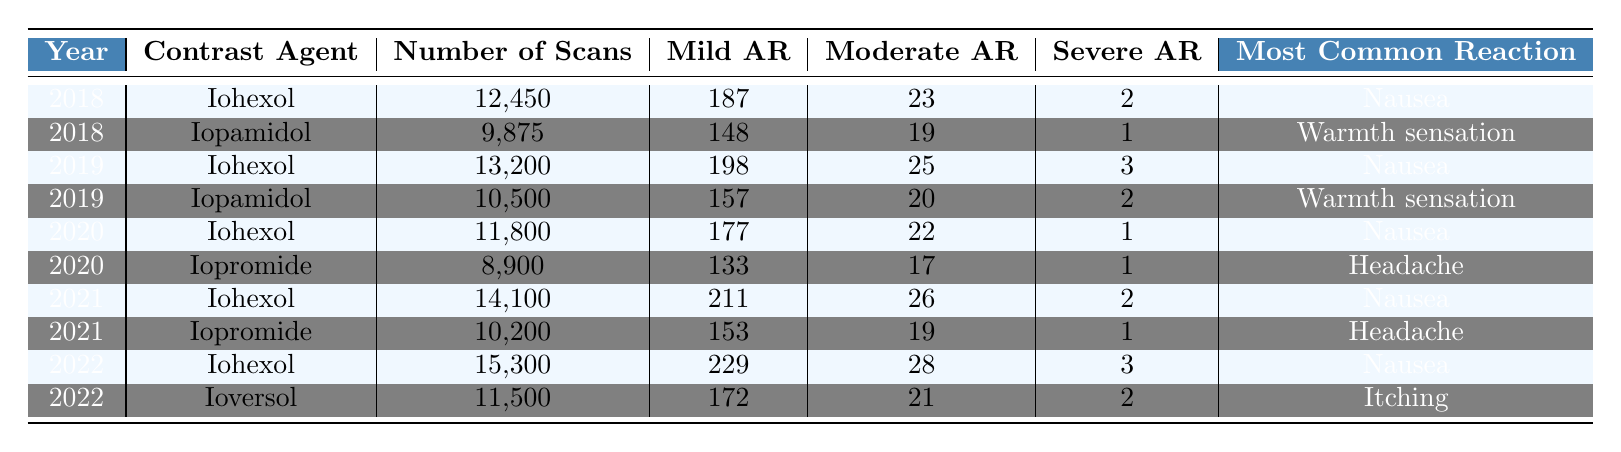What was the number of scans using Iohexol in 2020? In the table, under the year 2020, I can see that the number of scans using Iohexol is listed as 11,800.
Answer: 11,800 How many severe adverse reactions were reported for Iopamidol in 2019? In the table for the year 2019 and the contrast agent Iopamidol, the number of severe adverse reactions is given as 2.
Answer: 2 What is the total number of mild adverse reactions recorded for Iohexol from 2018 to 2022? To find the total number of mild adverse reactions for Iohexol, I will sum the mild adverse reactions across the years: 187 (2018) + 198 (2019) + 177 (2020) + 211 (2021) + 229 (2022) = 1,002.
Answer: 1,002 Which contrast agent had the highest number of moderate adverse reactions in 2021? Looking at the year 2021, Iohexol had 26 moderate adverse reactions, while Iopromide had 19. Thus, Iohexol had the highest.
Answer: Iohexol What is the average number of scans for Iopromide from 2020 to 2022? The number of scans for Iopromide in 2020 is 8,900, in 2021 is 10,200, and in 2022 is 0 (as it was not used). The average is (8,900 + 10,200 + 0) / 2 = 9,550 (since we only have two data points).
Answer: 9,550 Was there an increase in the number of scans using Iohexol from 2019 to 2022? In 2019, there were 13,200 scans with Iohexol, and in 2022, there were 15,300 scans. Since 15,300 is greater than 13,200, it indicates an increase.
Answer: Yes What is the most common adverse reaction associated with all contrast agents over the five years? By analyzing all rows in the table, the most common adverse reaction consistently listed for Iohexol is "Nausea," which appears in multiple years.
Answer: Nausea Which year had the lowest total number of scans across all contrast agents? By adding the number of scans for all agents per year: 2018: 12,450 + 9,875 = 22,325; 2019: 13,200 + 10,500 = 23,700; 2020: 11,800 + 8,900 = 20,700; 2021: 14,100 + 10,200 = 24,300; 2022: 15,300 + 11,500 = 26,800. The lowest total is for 2020 with 20,700.
Answer: 2020 How many total severe adverse reactions were observed in 2022? The table shows that in 2022, Iohexol had 3 severe reactions and Ioversol had 2 severe reactions. Adding these gives a total of 3 + 2 = 5.
Answer: 5 Which contrast agent had the most adverse reactions reported for the year 2022? In 2022, Iohexol reported 3 severe, 28 moderate, and 229 mild reactions, leading to a total of 260 adverse reactions. Ioversol had 2 severe, 21 moderate, and 172 mild reactions, leading to a total of 195 adverse reactions. Therefore, Iohexol had the most.
Answer: Iohexol 